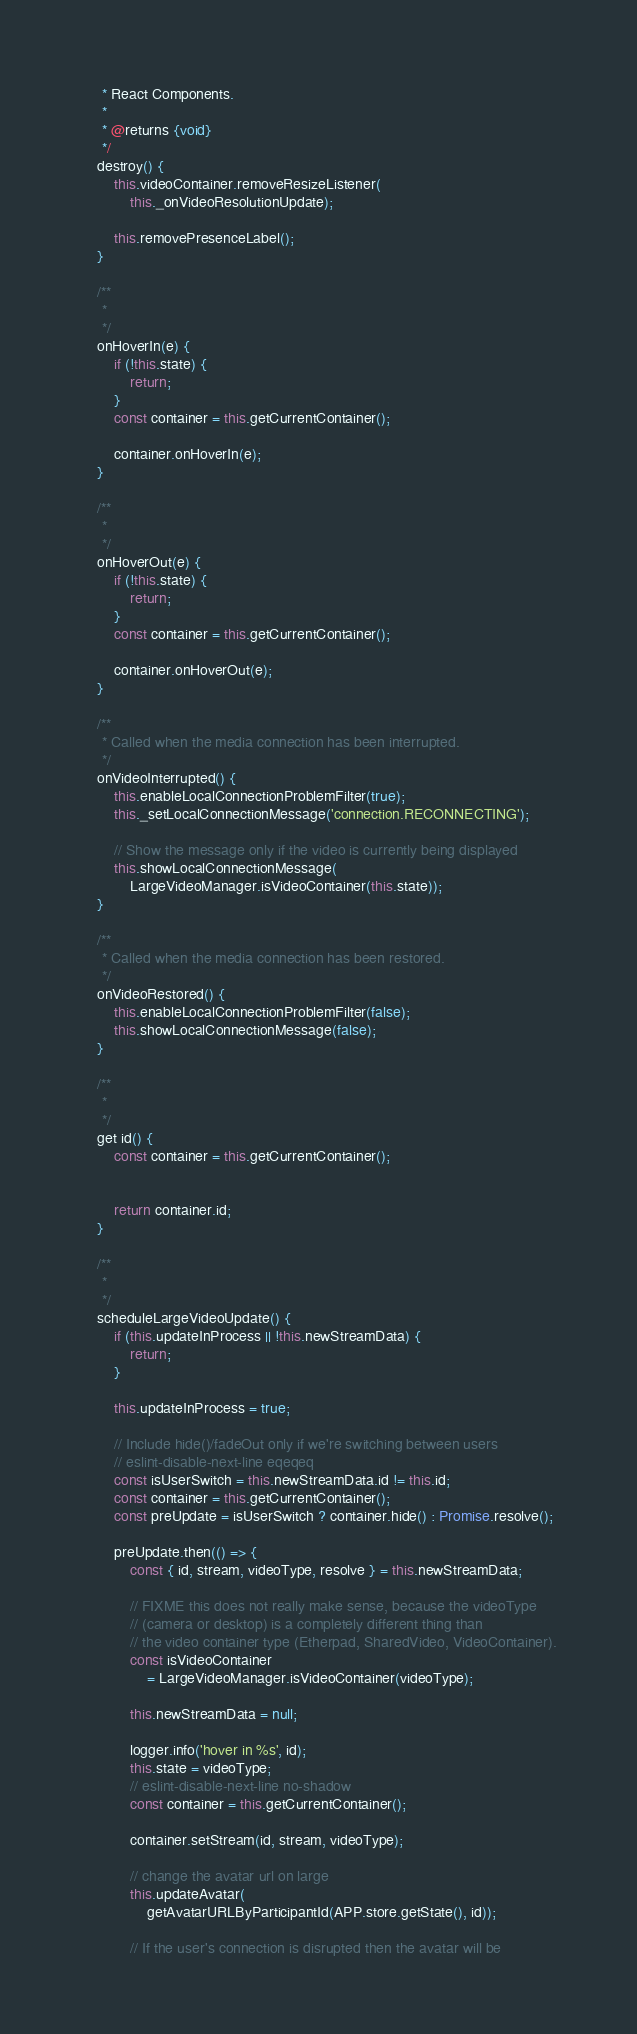Convert code to text. <code><loc_0><loc_0><loc_500><loc_500><_JavaScript_>     * React Components.
     *
     * @returns {void}
     */
    destroy() {
        this.videoContainer.removeResizeListener(
            this._onVideoResolutionUpdate);

        this.removePresenceLabel();
    }

    /**
     *
     */
    onHoverIn(e) {
        if (!this.state) {
            return;
        }
        const container = this.getCurrentContainer();

        container.onHoverIn(e);
    }

    /**
     *
     */
    onHoverOut(e) {
        if (!this.state) {
            return;
        }
        const container = this.getCurrentContainer();

        container.onHoverOut(e);
    }

    /**
     * Called when the media connection has been interrupted.
     */
    onVideoInterrupted() {
        this.enableLocalConnectionProblemFilter(true);
        this._setLocalConnectionMessage('connection.RECONNECTING');

        // Show the message only if the video is currently being displayed
        this.showLocalConnectionMessage(
            LargeVideoManager.isVideoContainer(this.state));
    }

    /**
     * Called when the media connection has been restored.
     */
    onVideoRestored() {
        this.enableLocalConnectionProblemFilter(false);
        this.showLocalConnectionMessage(false);
    }

    /**
     *
     */
    get id() {
        const container = this.getCurrentContainer();


        return container.id;
    }

    /**
     *
     */
    scheduleLargeVideoUpdate() {
        if (this.updateInProcess || !this.newStreamData) {
            return;
        }

        this.updateInProcess = true;

        // Include hide()/fadeOut only if we're switching between users
        // eslint-disable-next-line eqeqeq
        const isUserSwitch = this.newStreamData.id != this.id;
        const container = this.getCurrentContainer();
        const preUpdate = isUserSwitch ? container.hide() : Promise.resolve();

        preUpdate.then(() => {
            const { id, stream, videoType, resolve } = this.newStreamData;

            // FIXME this does not really make sense, because the videoType
            // (camera or desktop) is a completely different thing than
            // the video container type (Etherpad, SharedVideo, VideoContainer).
            const isVideoContainer
                = LargeVideoManager.isVideoContainer(videoType);

            this.newStreamData = null;

            logger.info('hover in %s', id);
            this.state = videoType;
            // eslint-disable-next-line no-shadow
            const container = this.getCurrentContainer();

            container.setStream(id, stream, videoType);

            // change the avatar url on large
            this.updateAvatar(
                getAvatarURLByParticipantId(APP.store.getState(), id));

            // If the user's connection is disrupted then the avatar will be</code> 